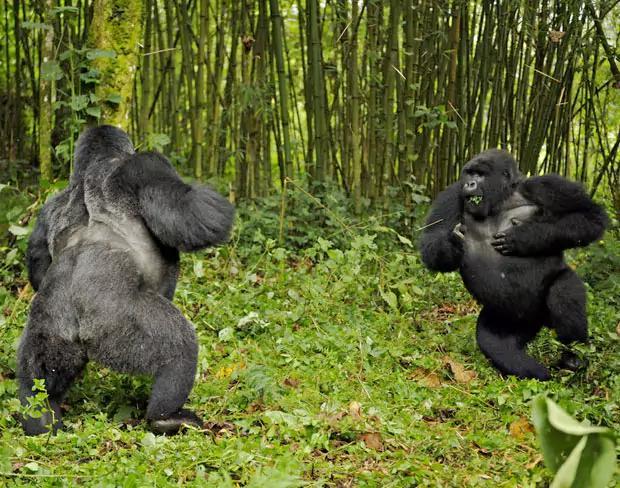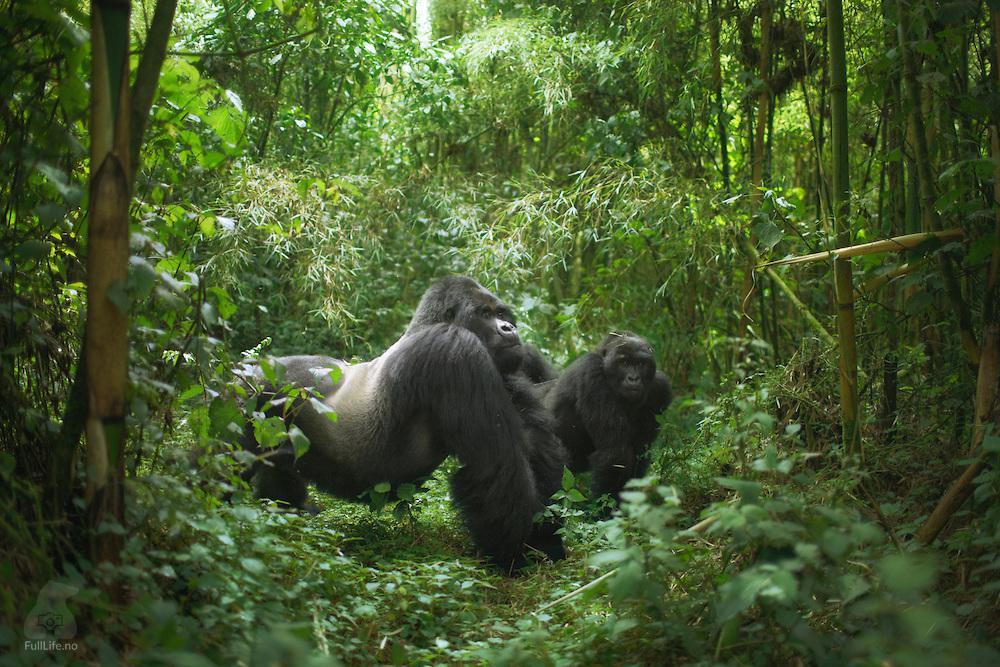The first image is the image on the left, the second image is the image on the right. Considering the images on both sides, is "Each image contains the same number of gorillas." valid? Answer yes or no. Yes. The first image is the image on the left, the second image is the image on the right. Evaluate the accuracy of this statement regarding the images: "In one of the pictures, a baby gorilla is near an adult gorilla.". Is it true? Answer yes or no. No. 